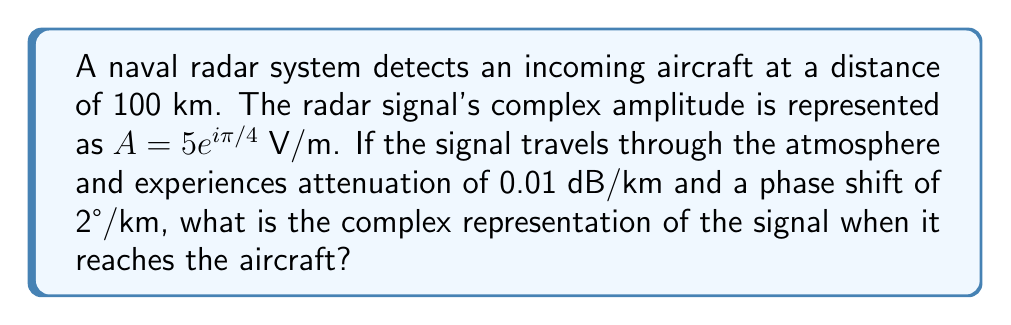Help me with this question. Let's approach this step-by-step:

1) First, we need to calculate the total attenuation and phase shift:
   - Attenuation: $100 \text{ km} \times 0.01 \text{ dB/km} = 1 \text{ dB}$
   - Phase shift: $100 \text{ km} \times 2°/\text{km} = 200°$

2) Convert the attenuation from dB to a linear scale:
   $\text{Attenuation factor} = 10^{-1/20} \approx 0.8913$

3) Convert the phase shift to radians:
   $200° \times \frac{\pi}{180°} \approx 3.4907 \text{ radians}$

4) The original signal is $A = 5e^{i\pi/4}$ V/m. We need to multiply this by the attenuation factor and add the phase shift:

   $A_{\text{new}} = 5 \times 0.8913 \times e^{i(\pi/4 + 3.4907)}$

5) Simplify:
   $A_{\text{new}} = 4.4565 \times e^{i(0.7854 + 3.4907)}$
   $A_{\text{new}} = 4.4565 \times e^{i4.2761}$

6) This can be left in polar form or converted to rectangular form:
   $A_{\text{new}} = 4.4565(\cos(4.2761) + i\sin(4.2761))$
   $A_{\text{new}} = -3.1833 - 3.1160i$ V/m
Answer: $4.4565e^{i4.2761}$ V/m or $-3.1833 - 3.1160i$ V/m 